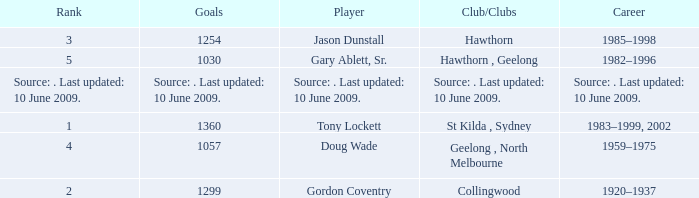What is the rank of player Jason Dunstall? 3.0. 